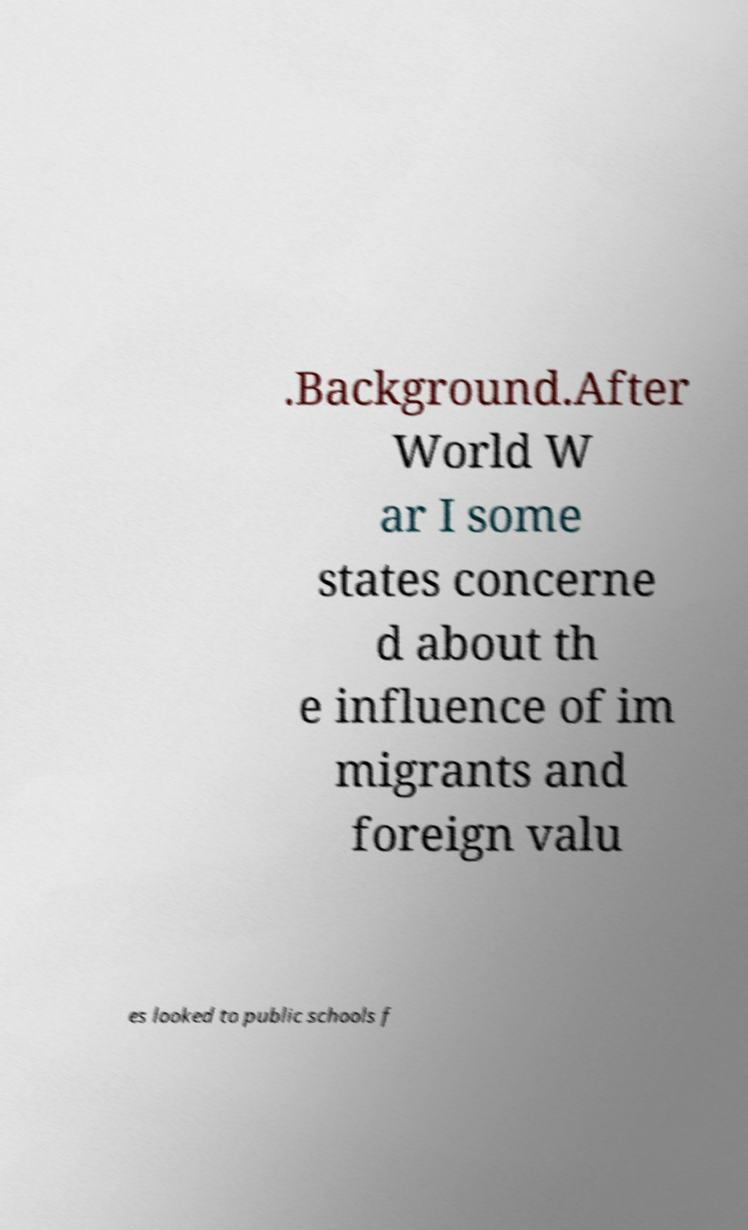Can you read and provide the text displayed in the image?This photo seems to have some interesting text. Can you extract and type it out for me? .Background.After World W ar I some states concerne d about th e influence of im migrants and foreign valu es looked to public schools f 